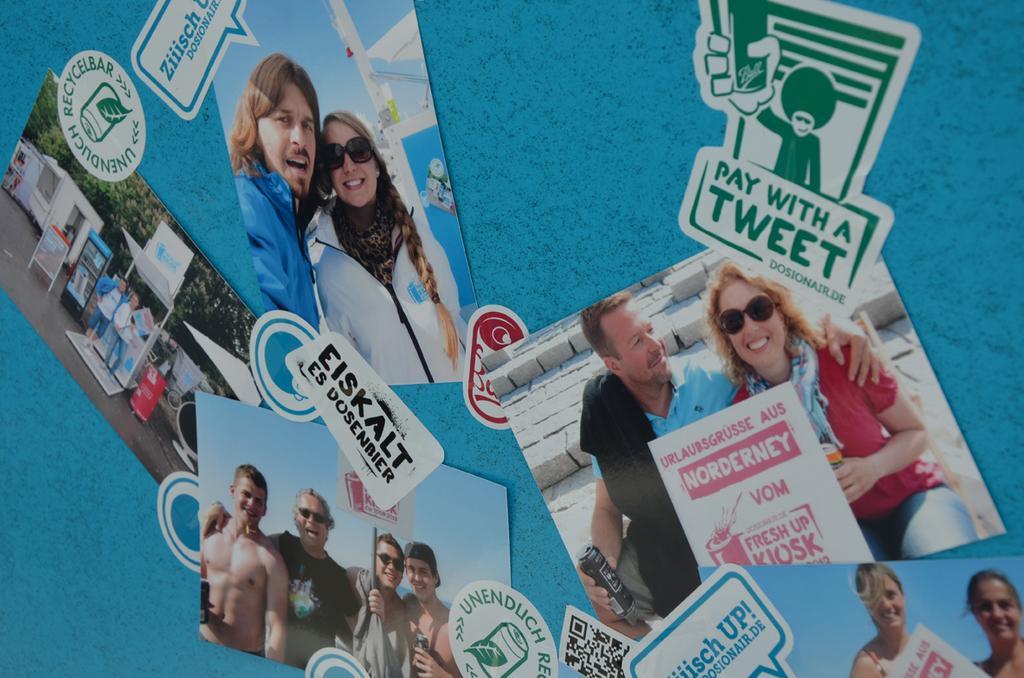How would you summarize this image in a sentence or two? In this image I can see posts on a wall. This image is taken, may be in a room. 